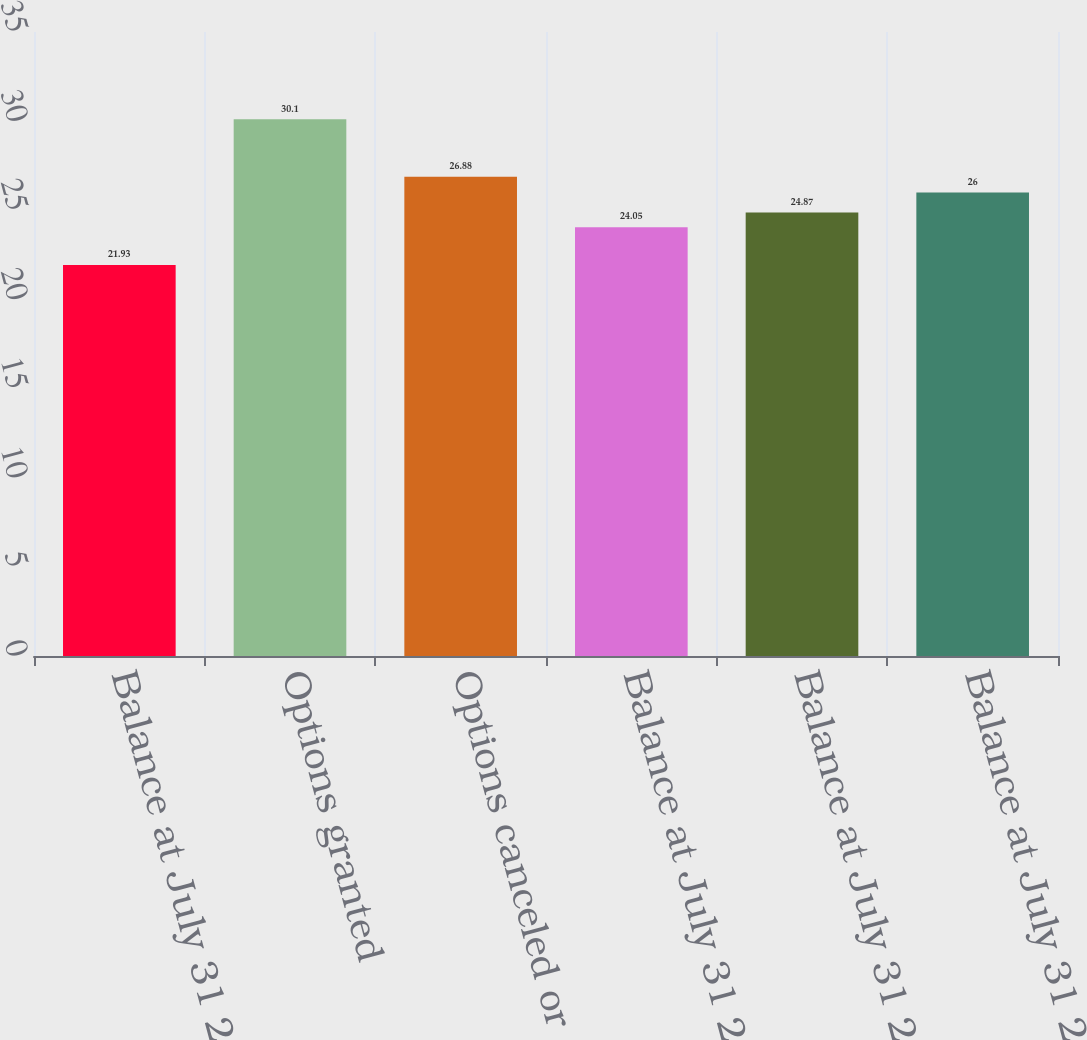Convert chart. <chart><loc_0><loc_0><loc_500><loc_500><bar_chart><fcel>Balance at July 31 2006<fcel>Options granted<fcel>Options canceled or expired<fcel>Balance at July 31 2007<fcel>Balance at July 31 2008<fcel>Balance at July 31 2009<nl><fcel>21.93<fcel>30.1<fcel>26.88<fcel>24.05<fcel>24.87<fcel>26<nl></chart> 